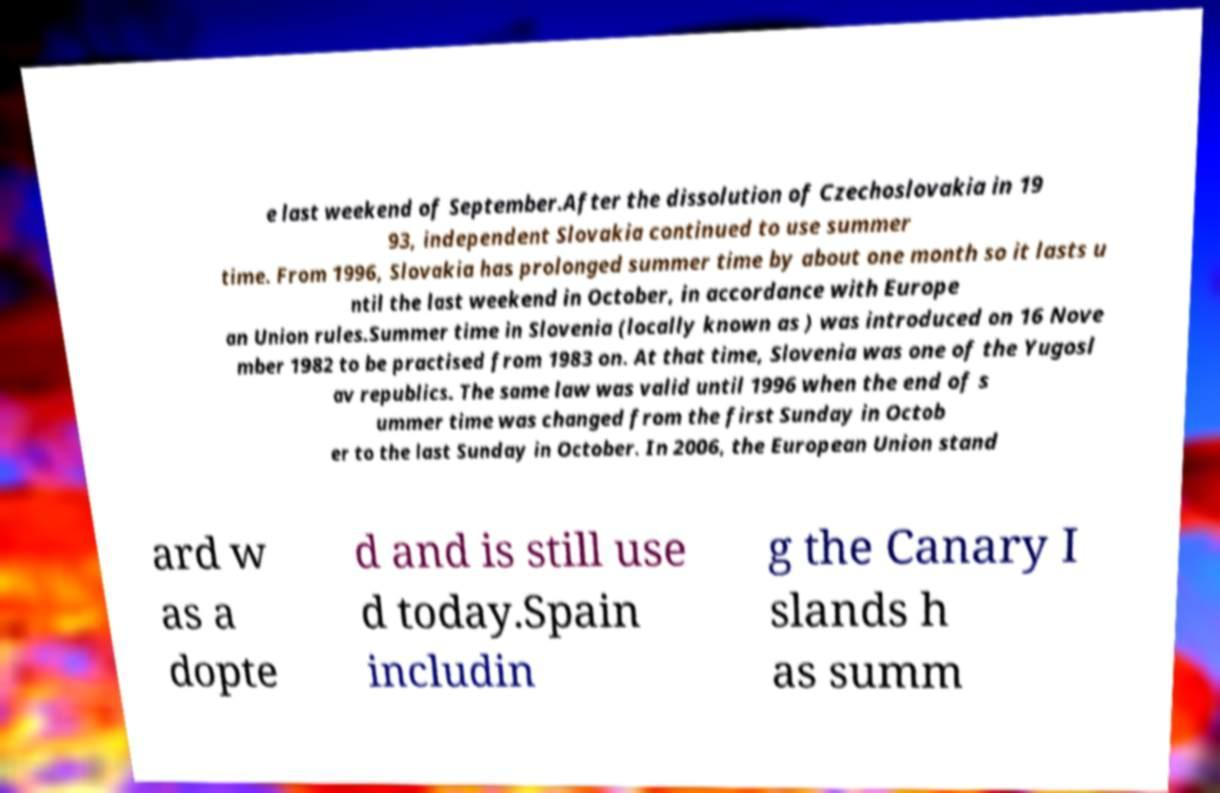There's text embedded in this image that I need extracted. Can you transcribe it verbatim? e last weekend of September.After the dissolution of Czechoslovakia in 19 93, independent Slovakia continued to use summer time. From 1996, Slovakia has prolonged summer time by about one month so it lasts u ntil the last weekend in October, in accordance with Europe an Union rules.Summer time in Slovenia (locally known as ) was introduced on 16 Nove mber 1982 to be practised from 1983 on. At that time, Slovenia was one of the Yugosl av republics. The same law was valid until 1996 when the end of s ummer time was changed from the first Sunday in Octob er to the last Sunday in October. In 2006, the European Union stand ard w as a dopte d and is still use d today.Spain includin g the Canary I slands h as summ 